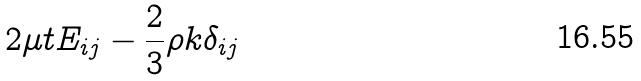<formula> <loc_0><loc_0><loc_500><loc_500>2 \mu t E _ { i j } - \frac { 2 } { 3 } \rho k \delta _ { i j }</formula> 